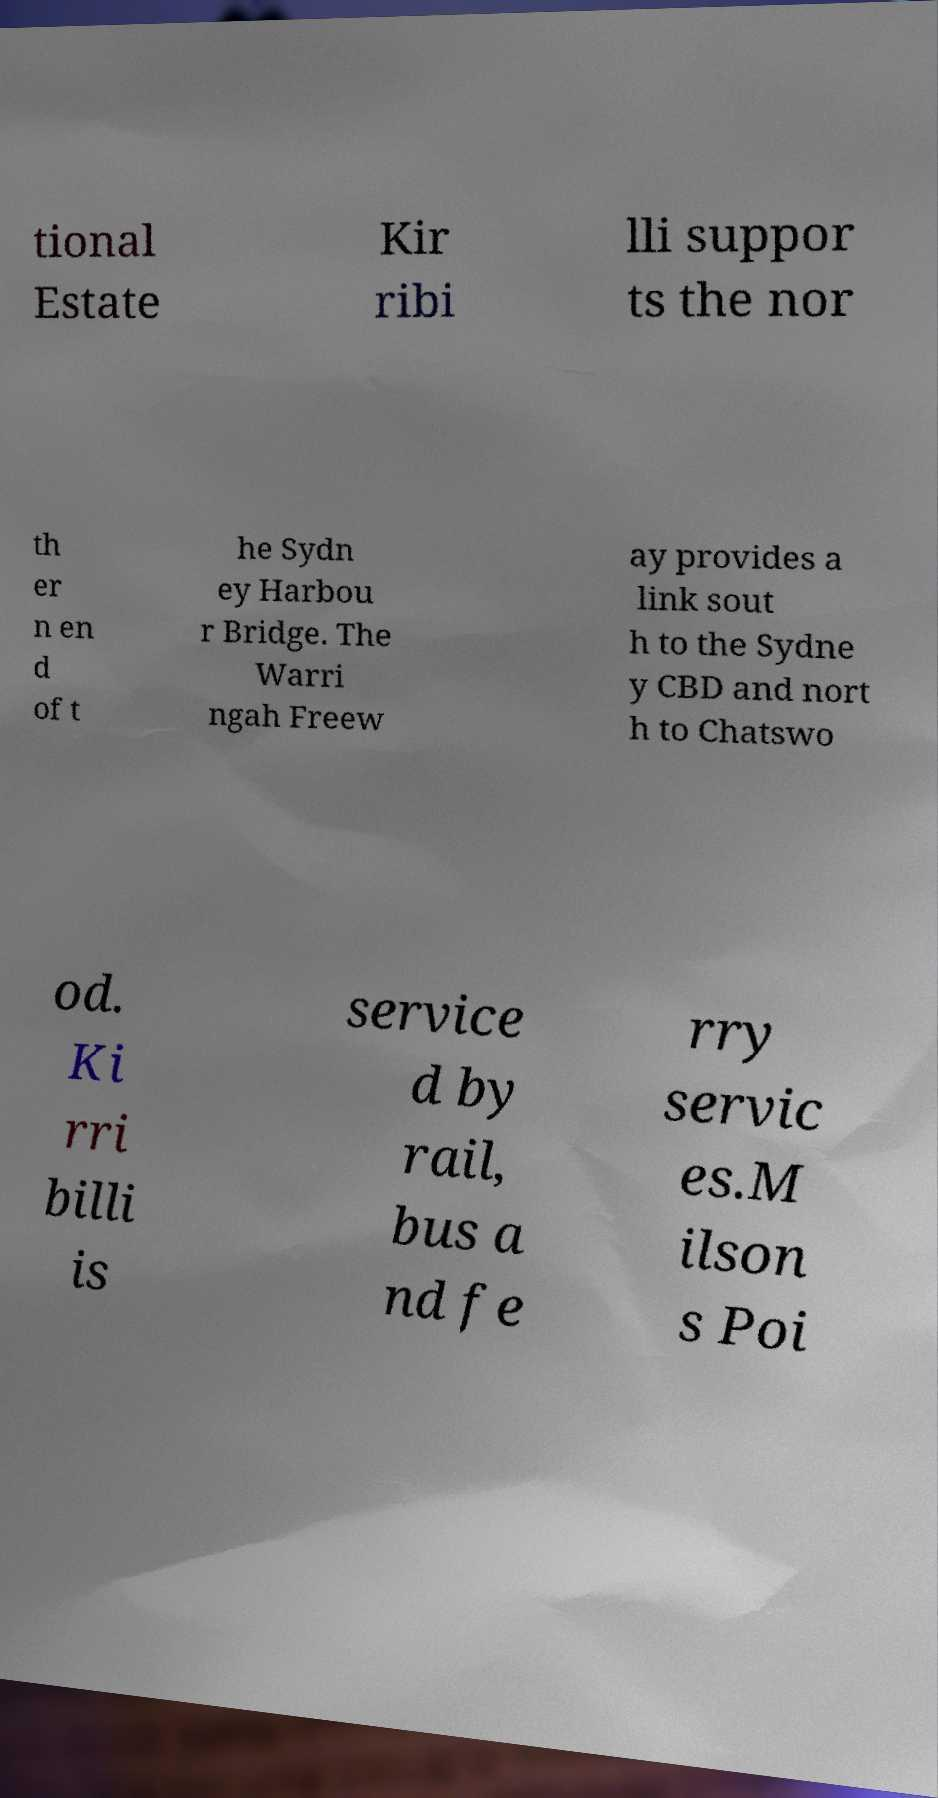Could you extract and type out the text from this image? tional Estate Kir ribi lli suppor ts the nor th er n en d of t he Sydn ey Harbou r Bridge. The Warri ngah Freew ay provides a link sout h to the Sydne y CBD and nort h to Chatswo od. Ki rri billi is service d by rail, bus a nd fe rry servic es.M ilson s Poi 